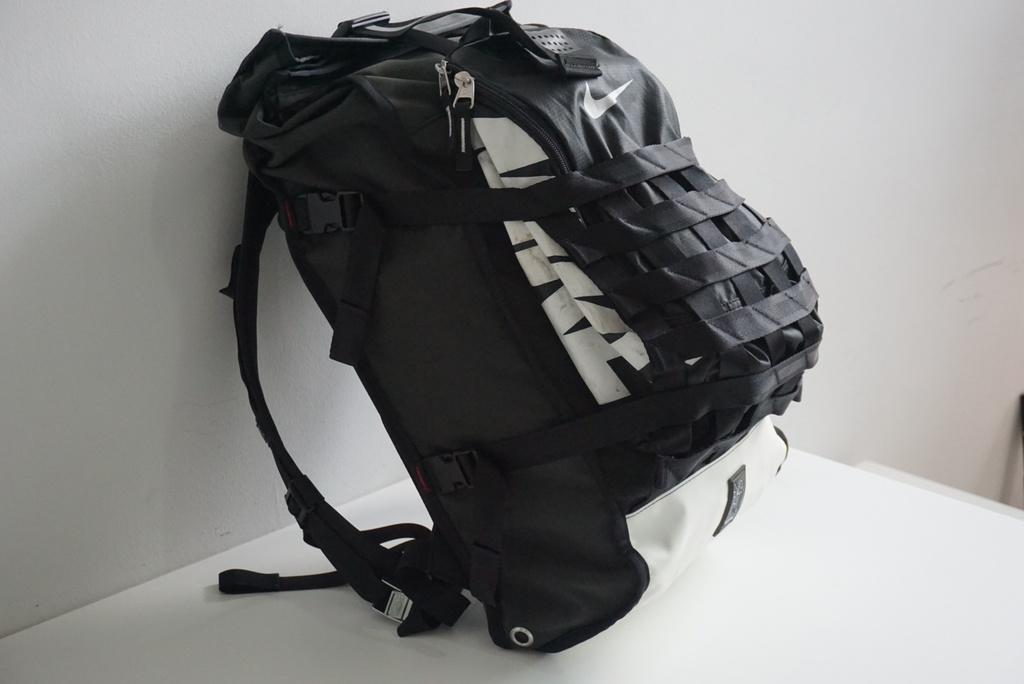What object is visible on the table in the image? There is a backpack on the table in the image. What color is the backpack? The backpack is black in color. What can be seen in the background of the image? There is a wall in the background of the image. What type of operation is being performed on the backpack in the image? There is no operation being performed on the backpack in the image; it is simply sitting on the table. Can you see a rake or any gardening tools in the image? No, there are no rakes or gardening tools present in the image. 